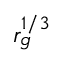<formula> <loc_0><loc_0><loc_500><loc_500>r _ { g } ^ { 1 / 3 }</formula> 